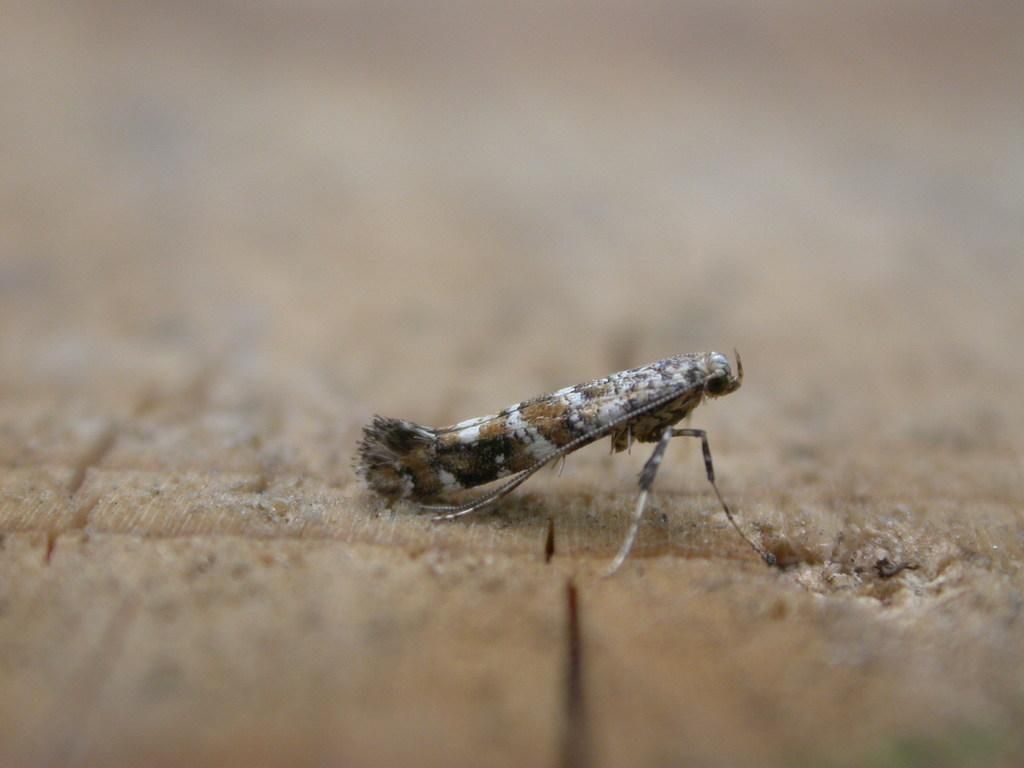What is located at the bottom of the image? There is a wooden platform at the bottom of the image. Can you describe the background of the image? The background of the image is blurred. What can be seen on the wooden platform in the image? There is a fly in the middle of the image on the wooden platform. What type of stocking is hanging from the fly in the image? There is no stocking present in the image, and the fly is not interacting with any stocking. How does the air in the image contribute to the expansion of the wooden platform? The air in the image does not contribute to the expansion of the wooden platform, as there is no indication of any expansion occurring. 